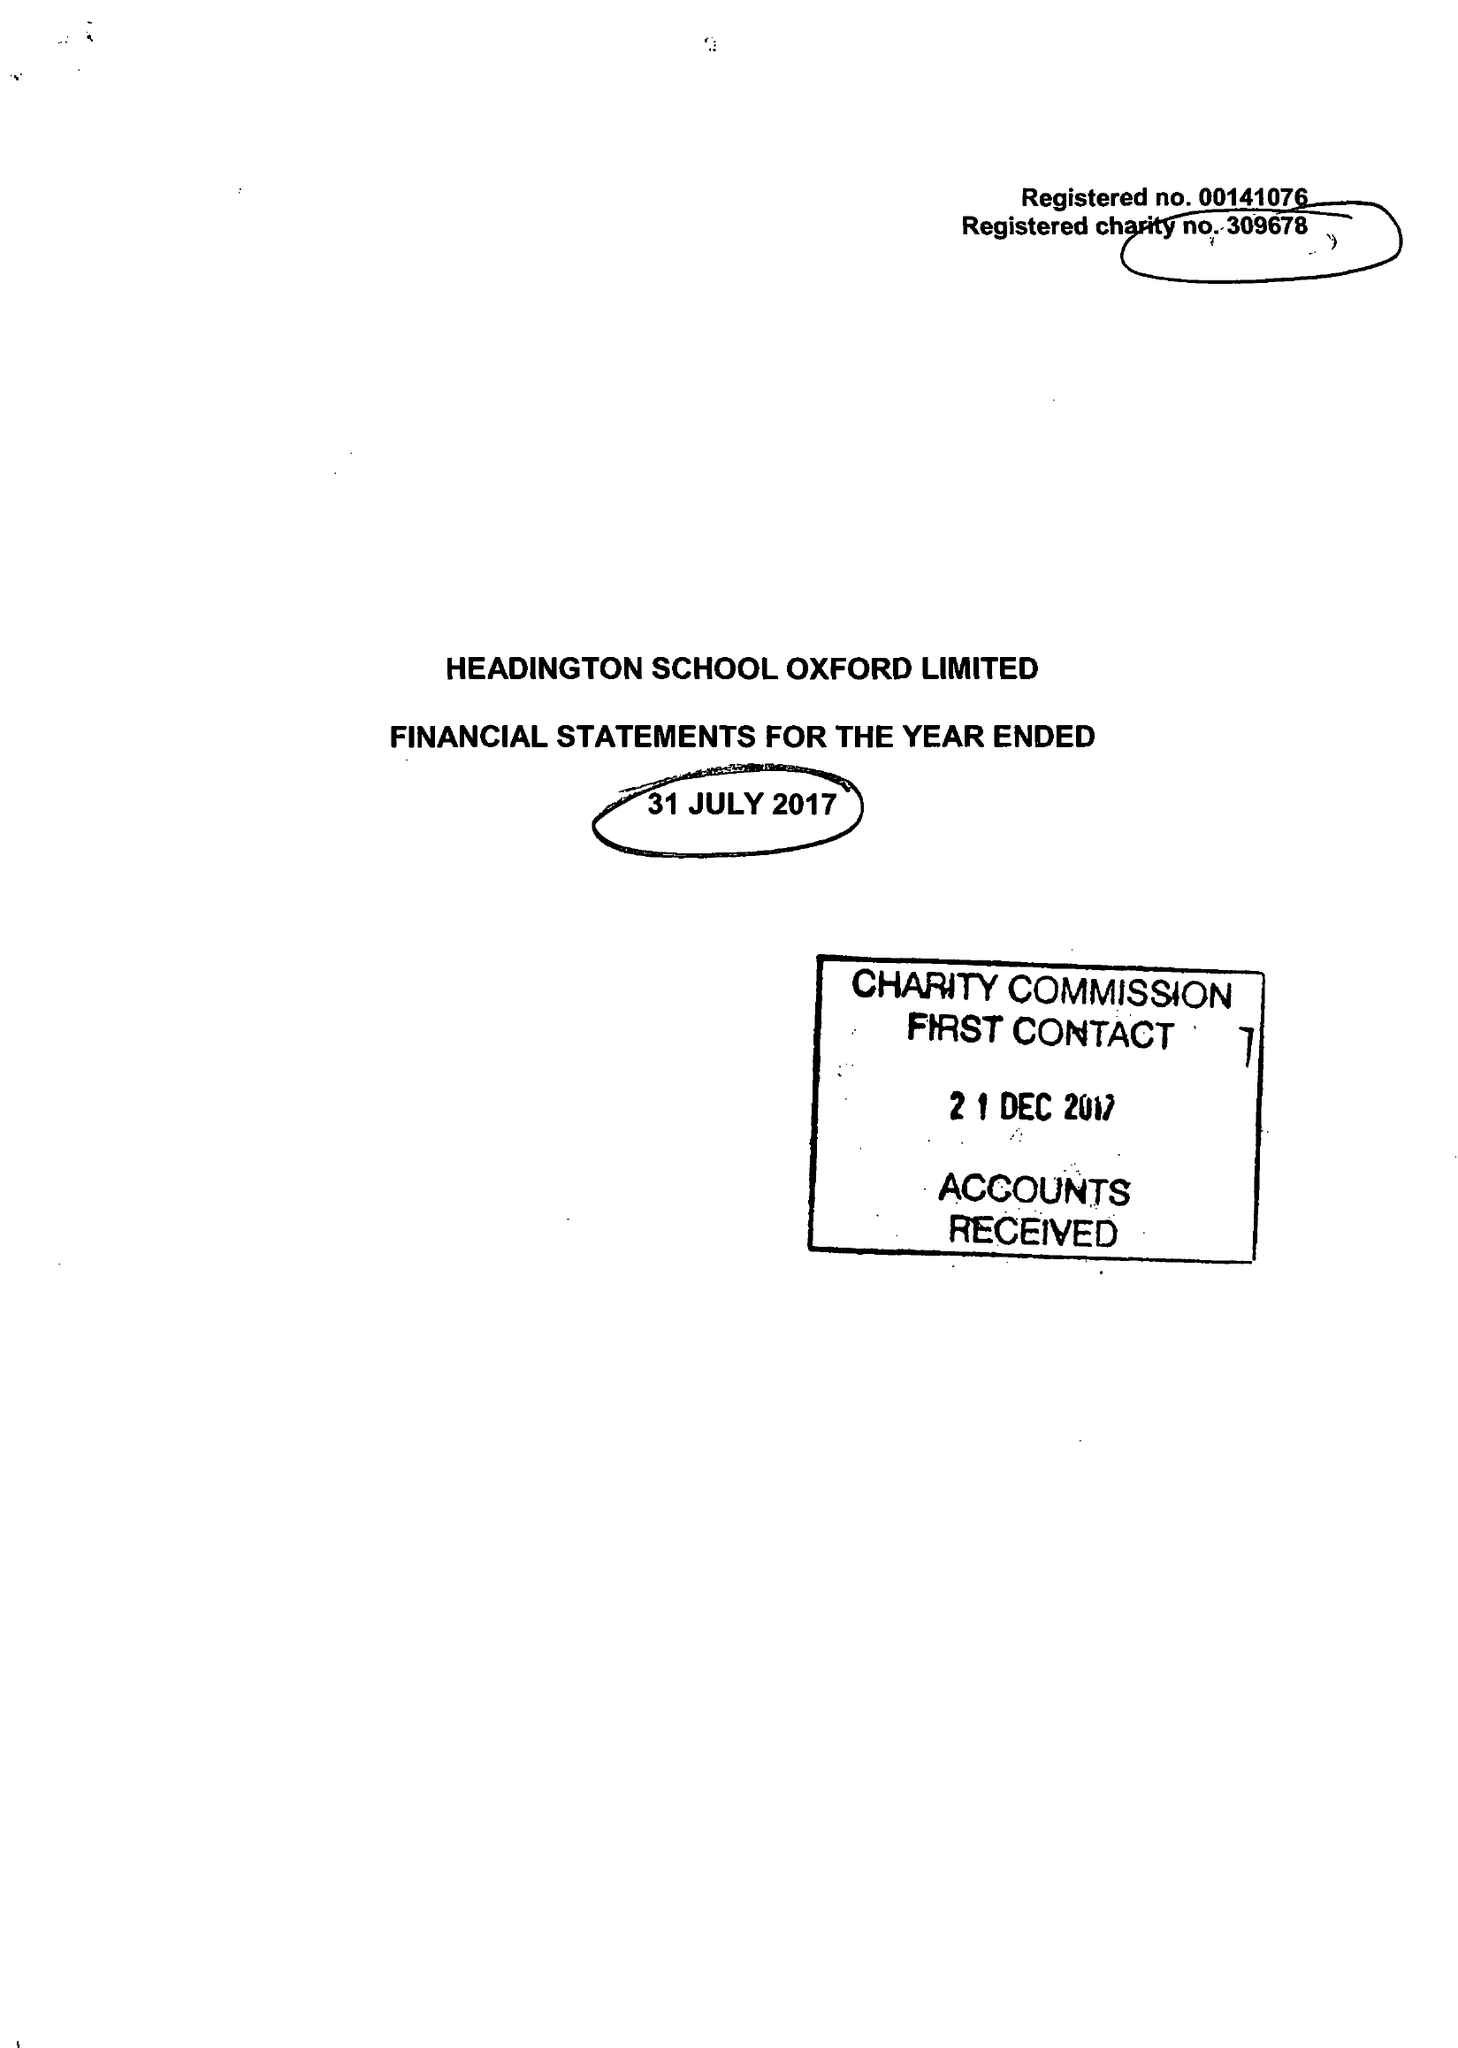What is the value for the spending_annually_in_british_pounds?
Answer the question using a single word or phrase. 19605952.00 